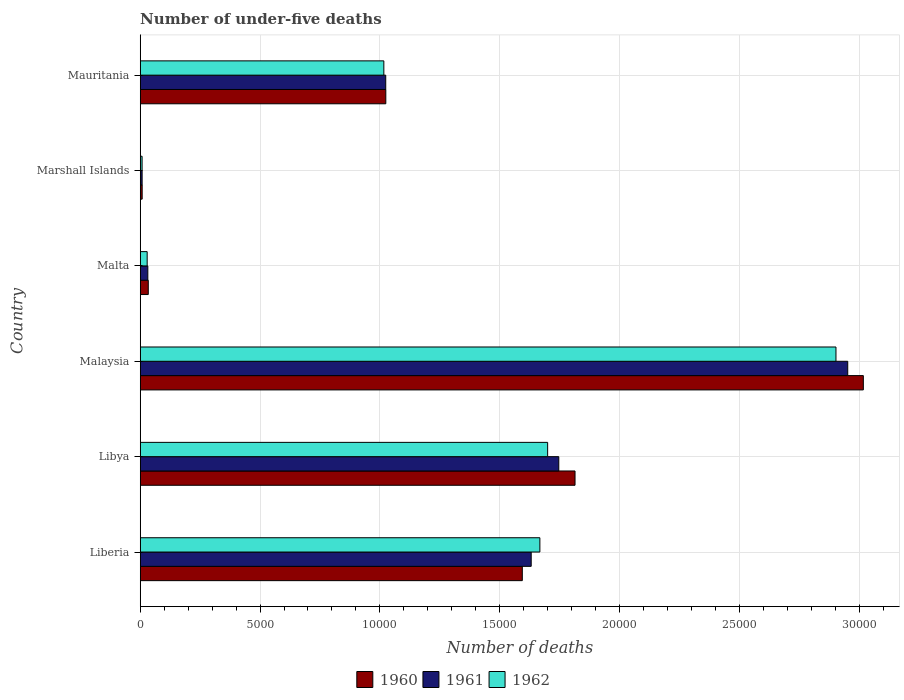Are the number of bars per tick equal to the number of legend labels?
Provide a succinct answer. Yes. How many bars are there on the 5th tick from the top?
Your answer should be very brief. 3. How many bars are there on the 2nd tick from the bottom?
Ensure brevity in your answer.  3. What is the label of the 4th group of bars from the top?
Provide a short and direct response. Malaysia. In how many cases, is the number of bars for a given country not equal to the number of legend labels?
Offer a very short reply. 0. What is the number of under-five deaths in 1960 in Malta?
Your answer should be compact. 336. Across all countries, what is the maximum number of under-five deaths in 1961?
Your answer should be compact. 2.95e+04. Across all countries, what is the minimum number of under-five deaths in 1961?
Your answer should be very brief. 79. In which country was the number of under-five deaths in 1962 maximum?
Offer a very short reply. Malaysia. In which country was the number of under-five deaths in 1961 minimum?
Your answer should be compact. Marshall Islands. What is the total number of under-five deaths in 1962 in the graph?
Give a very brief answer. 7.32e+04. What is the difference between the number of under-five deaths in 1960 in Malaysia and that in Marshall Islands?
Offer a very short reply. 3.01e+04. What is the difference between the number of under-five deaths in 1960 in Marshall Islands and the number of under-five deaths in 1961 in Libya?
Your answer should be very brief. -1.74e+04. What is the average number of under-five deaths in 1961 per country?
Offer a very short reply. 1.23e+04. What is the difference between the number of under-five deaths in 1962 and number of under-five deaths in 1960 in Malaysia?
Ensure brevity in your answer.  -1142. What is the ratio of the number of under-five deaths in 1962 in Malta to that in Mauritania?
Keep it short and to the point. 0.03. What is the difference between the highest and the second highest number of under-five deaths in 1960?
Your answer should be compact. 1.20e+04. What is the difference between the highest and the lowest number of under-five deaths in 1961?
Keep it short and to the point. 2.94e+04. Is the sum of the number of under-five deaths in 1960 in Libya and Marshall Islands greater than the maximum number of under-five deaths in 1962 across all countries?
Your answer should be very brief. No. What does the 3rd bar from the bottom in Marshall Islands represents?
Your response must be concise. 1962. Is it the case that in every country, the sum of the number of under-five deaths in 1962 and number of under-five deaths in 1961 is greater than the number of under-five deaths in 1960?
Offer a very short reply. Yes. How many bars are there?
Ensure brevity in your answer.  18. How many countries are there in the graph?
Make the answer very short. 6. What is the difference between two consecutive major ticks on the X-axis?
Your response must be concise. 5000. Does the graph contain any zero values?
Your response must be concise. No. What is the title of the graph?
Give a very brief answer. Number of under-five deaths. Does "2012" appear as one of the legend labels in the graph?
Ensure brevity in your answer.  No. What is the label or title of the X-axis?
Your response must be concise. Number of deaths. What is the Number of deaths of 1960 in Liberia?
Give a very brief answer. 1.59e+04. What is the Number of deaths of 1961 in Liberia?
Give a very brief answer. 1.63e+04. What is the Number of deaths in 1962 in Liberia?
Provide a short and direct response. 1.67e+04. What is the Number of deaths of 1960 in Libya?
Keep it short and to the point. 1.81e+04. What is the Number of deaths of 1961 in Libya?
Offer a very short reply. 1.75e+04. What is the Number of deaths in 1962 in Libya?
Provide a succinct answer. 1.70e+04. What is the Number of deaths of 1960 in Malaysia?
Offer a very short reply. 3.02e+04. What is the Number of deaths of 1961 in Malaysia?
Your response must be concise. 2.95e+04. What is the Number of deaths in 1962 in Malaysia?
Your answer should be compact. 2.90e+04. What is the Number of deaths of 1960 in Malta?
Make the answer very short. 336. What is the Number of deaths in 1961 in Malta?
Offer a very short reply. 317. What is the Number of deaths in 1962 in Malta?
Offer a terse response. 290. What is the Number of deaths of 1960 in Marshall Islands?
Offer a terse response. 81. What is the Number of deaths in 1961 in Marshall Islands?
Provide a succinct answer. 79. What is the Number of deaths of 1960 in Mauritania?
Offer a very short reply. 1.02e+04. What is the Number of deaths in 1961 in Mauritania?
Keep it short and to the point. 1.02e+04. What is the Number of deaths of 1962 in Mauritania?
Offer a terse response. 1.02e+04. Across all countries, what is the maximum Number of deaths in 1960?
Provide a short and direct response. 3.02e+04. Across all countries, what is the maximum Number of deaths of 1961?
Offer a terse response. 2.95e+04. Across all countries, what is the maximum Number of deaths in 1962?
Provide a short and direct response. 2.90e+04. Across all countries, what is the minimum Number of deaths in 1960?
Your answer should be very brief. 81. Across all countries, what is the minimum Number of deaths of 1961?
Your answer should be very brief. 79. What is the total Number of deaths of 1960 in the graph?
Your answer should be compact. 7.49e+04. What is the total Number of deaths of 1961 in the graph?
Ensure brevity in your answer.  7.39e+04. What is the total Number of deaths of 1962 in the graph?
Offer a terse response. 7.32e+04. What is the difference between the Number of deaths of 1960 in Liberia and that in Libya?
Give a very brief answer. -2200. What is the difference between the Number of deaths in 1961 in Liberia and that in Libya?
Give a very brief answer. -1151. What is the difference between the Number of deaths of 1962 in Liberia and that in Libya?
Offer a terse response. -324. What is the difference between the Number of deaths in 1960 in Liberia and that in Malaysia?
Your answer should be very brief. -1.42e+04. What is the difference between the Number of deaths of 1961 in Liberia and that in Malaysia?
Your answer should be compact. -1.32e+04. What is the difference between the Number of deaths in 1962 in Liberia and that in Malaysia?
Provide a short and direct response. -1.24e+04. What is the difference between the Number of deaths of 1960 in Liberia and that in Malta?
Keep it short and to the point. 1.56e+04. What is the difference between the Number of deaths of 1961 in Liberia and that in Malta?
Make the answer very short. 1.60e+04. What is the difference between the Number of deaths of 1962 in Liberia and that in Malta?
Offer a very short reply. 1.64e+04. What is the difference between the Number of deaths of 1960 in Liberia and that in Marshall Islands?
Your response must be concise. 1.59e+04. What is the difference between the Number of deaths in 1961 in Liberia and that in Marshall Islands?
Provide a succinct answer. 1.62e+04. What is the difference between the Number of deaths in 1962 in Liberia and that in Marshall Islands?
Offer a very short reply. 1.66e+04. What is the difference between the Number of deaths in 1960 in Liberia and that in Mauritania?
Your answer should be compact. 5696. What is the difference between the Number of deaths in 1961 in Liberia and that in Mauritania?
Provide a succinct answer. 6070. What is the difference between the Number of deaths of 1962 in Liberia and that in Mauritania?
Offer a very short reply. 6511. What is the difference between the Number of deaths in 1960 in Libya and that in Malaysia?
Ensure brevity in your answer.  -1.20e+04. What is the difference between the Number of deaths of 1961 in Libya and that in Malaysia?
Your response must be concise. -1.21e+04. What is the difference between the Number of deaths in 1962 in Libya and that in Malaysia?
Make the answer very short. -1.20e+04. What is the difference between the Number of deaths of 1960 in Libya and that in Malta?
Your response must be concise. 1.78e+04. What is the difference between the Number of deaths in 1961 in Libya and that in Malta?
Your answer should be compact. 1.71e+04. What is the difference between the Number of deaths of 1962 in Libya and that in Malta?
Offer a very short reply. 1.67e+04. What is the difference between the Number of deaths of 1960 in Libya and that in Marshall Islands?
Your answer should be compact. 1.81e+04. What is the difference between the Number of deaths in 1961 in Libya and that in Marshall Islands?
Provide a succinct answer. 1.74e+04. What is the difference between the Number of deaths in 1962 in Libya and that in Marshall Islands?
Your answer should be very brief. 1.69e+04. What is the difference between the Number of deaths of 1960 in Libya and that in Mauritania?
Keep it short and to the point. 7896. What is the difference between the Number of deaths in 1961 in Libya and that in Mauritania?
Provide a short and direct response. 7221. What is the difference between the Number of deaths in 1962 in Libya and that in Mauritania?
Your answer should be compact. 6835. What is the difference between the Number of deaths in 1960 in Malaysia and that in Malta?
Your answer should be compact. 2.98e+04. What is the difference between the Number of deaths of 1961 in Malaysia and that in Malta?
Provide a short and direct response. 2.92e+04. What is the difference between the Number of deaths of 1962 in Malaysia and that in Malta?
Provide a succinct answer. 2.87e+04. What is the difference between the Number of deaths of 1960 in Malaysia and that in Marshall Islands?
Your answer should be very brief. 3.01e+04. What is the difference between the Number of deaths of 1961 in Malaysia and that in Marshall Islands?
Your response must be concise. 2.94e+04. What is the difference between the Number of deaths of 1962 in Malaysia and that in Marshall Islands?
Your answer should be compact. 2.90e+04. What is the difference between the Number of deaths of 1960 in Malaysia and that in Mauritania?
Your answer should be compact. 1.99e+04. What is the difference between the Number of deaths in 1961 in Malaysia and that in Mauritania?
Your response must be concise. 1.93e+04. What is the difference between the Number of deaths in 1962 in Malaysia and that in Mauritania?
Your answer should be compact. 1.89e+04. What is the difference between the Number of deaths of 1960 in Malta and that in Marshall Islands?
Offer a very short reply. 255. What is the difference between the Number of deaths in 1961 in Malta and that in Marshall Islands?
Your answer should be compact. 238. What is the difference between the Number of deaths of 1962 in Malta and that in Marshall Islands?
Ensure brevity in your answer.  212. What is the difference between the Number of deaths of 1960 in Malta and that in Mauritania?
Make the answer very short. -9912. What is the difference between the Number of deaths of 1961 in Malta and that in Mauritania?
Provide a short and direct response. -9928. What is the difference between the Number of deaths of 1962 in Malta and that in Mauritania?
Offer a very short reply. -9876. What is the difference between the Number of deaths in 1960 in Marshall Islands and that in Mauritania?
Offer a terse response. -1.02e+04. What is the difference between the Number of deaths in 1961 in Marshall Islands and that in Mauritania?
Give a very brief answer. -1.02e+04. What is the difference between the Number of deaths of 1962 in Marshall Islands and that in Mauritania?
Your answer should be very brief. -1.01e+04. What is the difference between the Number of deaths of 1960 in Liberia and the Number of deaths of 1961 in Libya?
Give a very brief answer. -1522. What is the difference between the Number of deaths of 1960 in Liberia and the Number of deaths of 1962 in Libya?
Provide a short and direct response. -1057. What is the difference between the Number of deaths in 1961 in Liberia and the Number of deaths in 1962 in Libya?
Your response must be concise. -686. What is the difference between the Number of deaths of 1960 in Liberia and the Number of deaths of 1961 in Malaysia?
Offer a very short reply. -1.36e+04. What is the difference between the Number of deaths in 1960 in Liberia and the Number of deaths in 1962 in Malaysia?
Give a very brief answer. -1.31e+04. What is the difference between the Number of deaths of 1961 in Liberia and the Number of deaths of 1962 in Malaysia?
Give a very brief answer. -1.27e+04. What is the difference between the Number of deaths of 1960 in Liberia and the Number of deaths of 1961 in Malta?
Offer a very short reply. 1.56e+04. What is the difference between the Number of deaths in 1960 in Liberia and the Number of deaths in 1962 in Malta?
Ensure brevity in your answer.  1.57e+04. What is the difference between the Number of deaths of 1961 in Liberia and the Number of deaths of 1962 in Malta?
Ensure brevity in your answer.  1.60e+04. What is the difference between the Number of deaths of 1960 in Liberia and the Number of deaths of 1961 in Marshall Islands?
Your response must be concise. 1.59e+04. What is the difference between the Number of deaths of 1960 in Liberia and the Number of deaths of 1962 in Marshall Islands?
Ensure brevity in your answer.  1.59e+04. What is the difference between the Number of deaths in 1961 in Liberia and the Number of deaths in 1962 in Marshall Islands?
Your answer should be compact. 1.62e+04. What is the difference between the Number of deaths of 1960 in Liberia and the Number of deaths of 1961 in Mauritania?
Offer a very short reply. 5699. What is the difference between the Number of deaths in 1960 in Liberia and the Number of deaths in 1962 in Mauritania?
Ensure brevity in your answer.  5778. What is the difference between the Number of deaths of 1961 in Liberia and the Number of deaths of 1962 in Mauritania?
Keep it short and to the point. 6149. What is the difference between the Number of deaths in 1960 in Libya and the Number of deaths in 1961 in Malaysia?
Provide a succinct answer. -1.14e+04. What is the difference between the Number of deaths in 1960 in Libya and the Number of deaths in 1962 in Malaysia?
Your response must be concise. -1.09e+04. What is the difference between the Number of deaths of 1961 in Libya and the Number of deaths of 1962 in Malaysia?
Offer a very short reply. -1.16e+04. What is the difference between the Number of deaths in 1960 in Libya and the Number of deaths in 1961 in Malta?
Provide a succinct answer. 1.78e+04. What is the difference between the Number of deaths in 1960 in Libya and the Number of deaths in 1962 in Malta?
Offer a very short reply. 1.79e+04. What is the difference between the Number of deaths of 1961 in Libya and the Number of deaths of 1962 in Malta?
Offer a terse response. 1.72e+04. What is the difference between the Number of deaths in 1960 in Libya and the Number of deaths in 1961 in Marshall Islands?
Make the answer very short. 1.81e+04. What is the difference between the Number of deaths in 1960 in Libya and the Number of deaths in 1962 in Marshall Islands?
Make the answer very short. 1.81e+04. What is the difference between the Number of deaths in 1961 in Libya and the Number of deaths in 1962 in Marshall Islands?
Provide a short and direct response. 1.74e+04. What is the difference between the Number of deaths in 1960 in Libya and the Number of deaths in 1961 in Mauritania?
Make the answer very short. 7899. What is the difference between the Number of deaths in 1960 in Libya and the Number of deaths in 1962 in Mauritania?
Your answer should be compact. 7978. What is the difference between the Number of deaths of 1961 in Libya and the Number of deaths of 1962 in Mauritania?
Your answer should be very brief. 7300. What is the difference between the Number of deaths in 1960 in Malaysia and the Number of deaths in 1961 in Malta?
Keep it short and to the point. 2.99e+04. What is the difference between the Number of deaths in 1960 in Malaysia and the Number of deaths in 1962 in Malta?
Provide a short and direct response. 2.99e+04. What is the difference between the Number of deaths in 1961 in Malaysia and the Number of deaths in 1962 in Malta?
Make the answer very short. 2.92e+04. What is the difference between the Number of deaths in 1960 in Malaysia and the Number of deaths in 1961 in Marshall Islands?
Ensure brevity in your answer.  3.01e+04. What is the difference between the Number of deaths of 1960 in Malaysia and the Number of deaths of 1962 in Marshall Islands?
Your answer should be compact. 3.01e+04. What is the difference between the Number of deaths in 1961 in Malaysia and the Number of deaths in 1962 in Marshall Islands?
Give a very brief answer. 2.94e+04. What is the difference between the Number of deaths in 1960 in Malaysia and the Number of deaths in 1961 in Mauritania?
Give a very brief answer. 1.99e+04. What is the difference between the Number of deaths in 1960 in Malaysia and the Number of deaths in 1962 in Mauritania?
Keep it short and to the point. 2.00e+04. What is the difference between the Number of deaths of 1961 in Malaysia and the Number of deaths of 1962 in Mauritania?
Your answer should be compact. 1.94e+04. What is the difference between the Number of deaths in 1960 in Malta and the Number of deaths in 1961 in Marshall Islands?
Give a very brief answer. 257. What is the difference between the Number of deaths of 1960 in Malta and the Number of deaths of 1962 in Marshall Islands?
Give a very brief answer. 258. What is the difference between the Number of deaths in 1961 in Malta and the Number of deaths in 1962 in Marshall Islands?
Provide a succinct answer. 239. What is the difference between the Number of deaths in 1960 in Malta and the Number of deaths in 1961 in Mauritania?
Your answer should be very brief. -9909. What is the difference between the Number of deaths of 1960 in Malta and the Number of deaths of 1962 in Mauritania?
Your answer should be compact. -9830. What is the difference between the Number of deaths in 1961 in Malta and the Number of deaths in 1962 in Mauritania?
Give a very brief answer. -9849. What is the difference between the Number of deaths in 1960 in Marshall Islands and the Number of deaths in 1961 in Mauritania?
Make the answer very short. -1.02e+04. What is the difference between the Number of deaths in 1960 in Marshall Islands and the Number of deaths in 1962 in Mauritania?
Your answer should be very brief. -1.01e+04. What is the difference between the Number of deaths of 1961 in Marshall Islands and the Number of deaths of 1962 in Mauritania?
Your response must be concise. -1.01e+04. What is the average Number of deaths of 1960 per country?
Your response must be concise. 1.25e+04. What is the average Number of deaths of 1961 per country?
Provide a succinct answer. 1.23e+04. What is the average Number of deaths in 1962 per country?
Offer a terse response. 1.22e+04. What is the difference between the Number of deaths of 1960 and Number of deaths of 1961 in Liberia?
Provide a succinct answer. -371. What is the difference between the Number of deaths in 1960 and Number of deaths in 1962 in Liberia?
Your answer should be very brief. -733. What is the difference between the Number of deaths in 1961 and Number of deaths in 1962 in Liberia?
Provide a short and direct response. -362. What is the difference between the Number of deaths of 1960 and Number of deaths of 1961 in Libya?
Ensure brevity in your answer.  678. What is the difference between the Number of deaths of 1960 and Number of deaths of 1962 in Libya?
Your answer should be compact. 1143. What is the difference between the Number of deaths of 1961 and Number of deaths of 1962 in Libya?
Keep it short and to the point. 465. What is the difference between the Number of deaths in 1960 and Number of deaths in 1961 in Malaysia?
Offer a terse response. 651. What is the difference between the Number of deaths in 1960 and Number of deaths in 1962 in Malaysia?
Your response must be concise. 1142. What is the difference between the Number of deaths in 1961 and Number of deaths in 1962 in Malaysia?
Make the answer very short. 491. What is the difference between the Number of deaths in 1960 and Number of deaths in 1962 in Malta?
Make the answer very short. 46. What is the difference between the Number of deaths in 1961 and Number of deaths in 1962 in Malta?
Offer a very short reply. 27. What is the difference between the Number of deaths of 1961 and Number of deaths of 1962 in Marshall Islands?
Make the answer very short. 1. What is the difference between the Number of deaths of 1960 and Number of deaths of 1962 in Mauritania?
Your answer should be very brief. 82. What is the difference between the Number of deaths of 1961 and Number of deaths of 1962 in Mauritania?
Give a very brief answer. 79. What is the ratio of the Number of deaths of 1960 in Liberia to that in Libya?
Offer a terse response. 0.88. What is the ratio of the Number of deaths of 1961 in Liberia to that in Libya?
Offer a terse response. 0.93. What is the ratio of the Number of deaths of 1962 in Liberia to that in Libya?
Your answer should be compact. 0.98. What is the ratio of the Number of deaths in 1960 in Liberia to that in Malaysia?
Your answer should be very brief. 0.53. What is the ratio of the Number of deaths of 1961 in Liberia to that in Malaysia?
Your response must be concise. 0.55. What is the ratio of the Number of deaths of 1962 in Liberia to that in Malaysia?
Your response must be concise. 0.57. What is the ratio of the Number of deaths in 1960 in Liberia to that in Malta?
Provide a succinct answer. 47.45. What is the ratio of the Number of deaths of 1961 in Liberia to that in Malta?
Offer a very short reply. 51.47. What is the ratio of the Number of deaths of 1962 in Liberia to that in Malta?
Ensure brevity in your answer.  57.51. What is the ratio of the Number of deaths in 1960 in Liberia to that in Marshall Islands?
Your answer should be compact. 196.84. What is the ratio of the Number of deaths of 1961 in Liberia to that in Marshall Islands?
Your answer should be very brief. 206.52. What is the ratio of the Number of deaths of 1962 in Liberia to that in Marshall Islands?
Ensure brevity in your answer.  213.81. What is the ratio of the Number of deaths of 1960 in Liberia to that in Mauritania?
Your answer should be very brief. 1.56. What is the ratio of the Number of deaths of 1961 in Liberia to that in Mauritania?
Offer a very short reply. 1.59. What is the ratio of the Number of deaths in 1962 in Liberia to that in Mauritania?
Make the answer very short. 1.64. What is the ratio of the Number of deaths in 1960 in Libya to that in Malaysia?
Give a very brief answer. 0.6. What is the ratio of the Number of deaths of 1961 in Libya to that in Malaysia?
Your answer should be compact. 0.59. What is the ratio of the Number of deaths in 1962 in Libya to that in Malaysia?
Make the answer very short. 0.59. What is the ratio of the Number of deaths in 1961 in Libya to that in Malta?
Keep it short and to the point. 55.1. What is the ratio of the Number of deaths of 1962 in Libya to that in Malta?
Offer a very short reply. 58.62. What is the ratio of the Number of deaths of 1960 in Libya to that in Marshall Islands?
Ensure brevity in your answer.  224. What is the ratio of the Number of deaths in 1961 in Libya to that in Marshall Islands?
Your answer should be compact. 221.09. What is the ratio of the Number of deaths of 1962 in Libya to that in Marshall Islands?
Make the answer very short. 217.96. What is the ratio of the Number of deaths of 1960 in Libya to that in Mauritania?
Provide a succinct answer. 1.77. What is the ratio of the Number of deaths of 1961 in Libya to that in Mauritania?
Give a very brief answer. 1.7. What is the ratio of the Number of deaths in 1962 in Libya to that in Mauritania?
Ensure brevity in your answer.  1.67. What is the ratio of the Number of deaths in 1960 in Malaysia to that in Malta?
Provide a short and direct response. 89.81. What is the ratio of the Number of deaths in 1961 in Malaysia to that in Malta?
Keep it short and to the point. 93.14. What is the ratio of the Number of deaths in 1962 in Malaysia to that in Malta?
Offer a terse response. 100.11. What is the ratio of the Number of deaths in 1960 in Malaysia to that in Marshall Islands?
Offer a terse response. 372.53. What is the ratio of the Number of deaths of 1961 in Malaysia to that in Marshall Islands?
Your response must be concise. 373.72. What is the ratio of the Number of deaths in 1962 in Malaysia to that in Marshall Islands?
Offer a terse response. 372.22. What is the ratio of the Number of deaths in 1960 in Malaysia to that in Mauritania?
Offer a terse response. 2.94. What is the ratio of the Number of deaths in 1961 in Malaysia to that in Mauritania?
Your response must be concise. 2.88. What is the ratio of the Number of deaths of 1962 in Malaysia to that in Mauritania?
Your answer should be very brief. 2.86. What is the ratio of the Number of deaths in 1960 in Malta to that in Marshall Islands?
Your answer should be compact. 4.15. What is the ratio of the Number of deaths of 1961 in Malta to that in Marshall Islands?
Give a very brief answer. 4.01. What is the ratio of the Number of deaths of 1962 in Malta to that in Marshall Islands?
Your response must be concise. 3.72. What is the ratio of the Number of deaths in 1960 in Malta to that in Mauritania?
Make the answer very short. 0.03. What is the ratio of the Number of deaths of 1961 in Malta to that in Mauritania?
Your answer should be compact. 0.03. What is the ratio of the Number of deaths of 1962 in Malta to that in Mauritania?
Ensure brevity in your answer.  0.03. What is the ratio of the Number of deaths in 1960 in Marshall Islands to that in Mauritania?
Provide a short and direct response. 0.01. What is the ratio of the Number of deaths of 1961 in Marshall Islands to that in Mauritania?
Give a very brief answer. 0.01. What is the ratio of the Number of deaths in 1962 in Marshall Islands to that in Mauritania?
Keep it short and to the point. 0.01. What is the difference between the highest and the second highest Number of deaths of 1960?
Provide a succinct answer. 1.20e+04. What is the difference between the highest and the second highest Number of deaths of 1961?
Offer a terse response. 1.21e+04. What is the difference between the highest and the second highest Number of deaths of 1962?
Keep it short and to the point. 1.20e+04. What is the difference between the highest and the lowest Number of deaths of 1960?
Ensure brevity in your answer.  3.01e+04. What is the difference between the highest and the lowest Number of deaths of 1961?
Provide a succinct answer. 2.94e+04. What is the difference between the highest and the lowest Number of deaths in 1962?
Your response must be concise. 2.90e+04. 